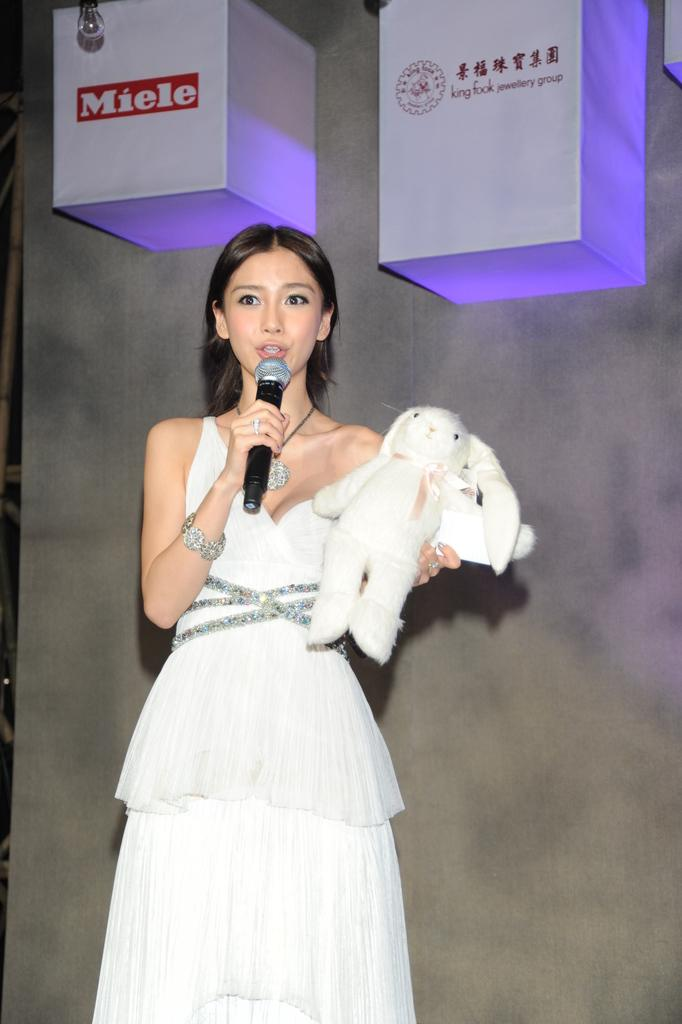Who is the main subject in the image? There is a lady in the image. What is the lady holding in her hand? The lady is holding a mic in her hand. What else is the lady holding in her other hand? The lady is holding a white doll in her other hand. What can be seen in the background of the image? There are two boxes in the background of the image, and one of them is labeled "MIELE". How many cakes are displayed on the vest in the image? There are no cakes or vests present in the image. What fact can be learned about the lady's profession from the image? The image does not provide any information about the lady's profession. 